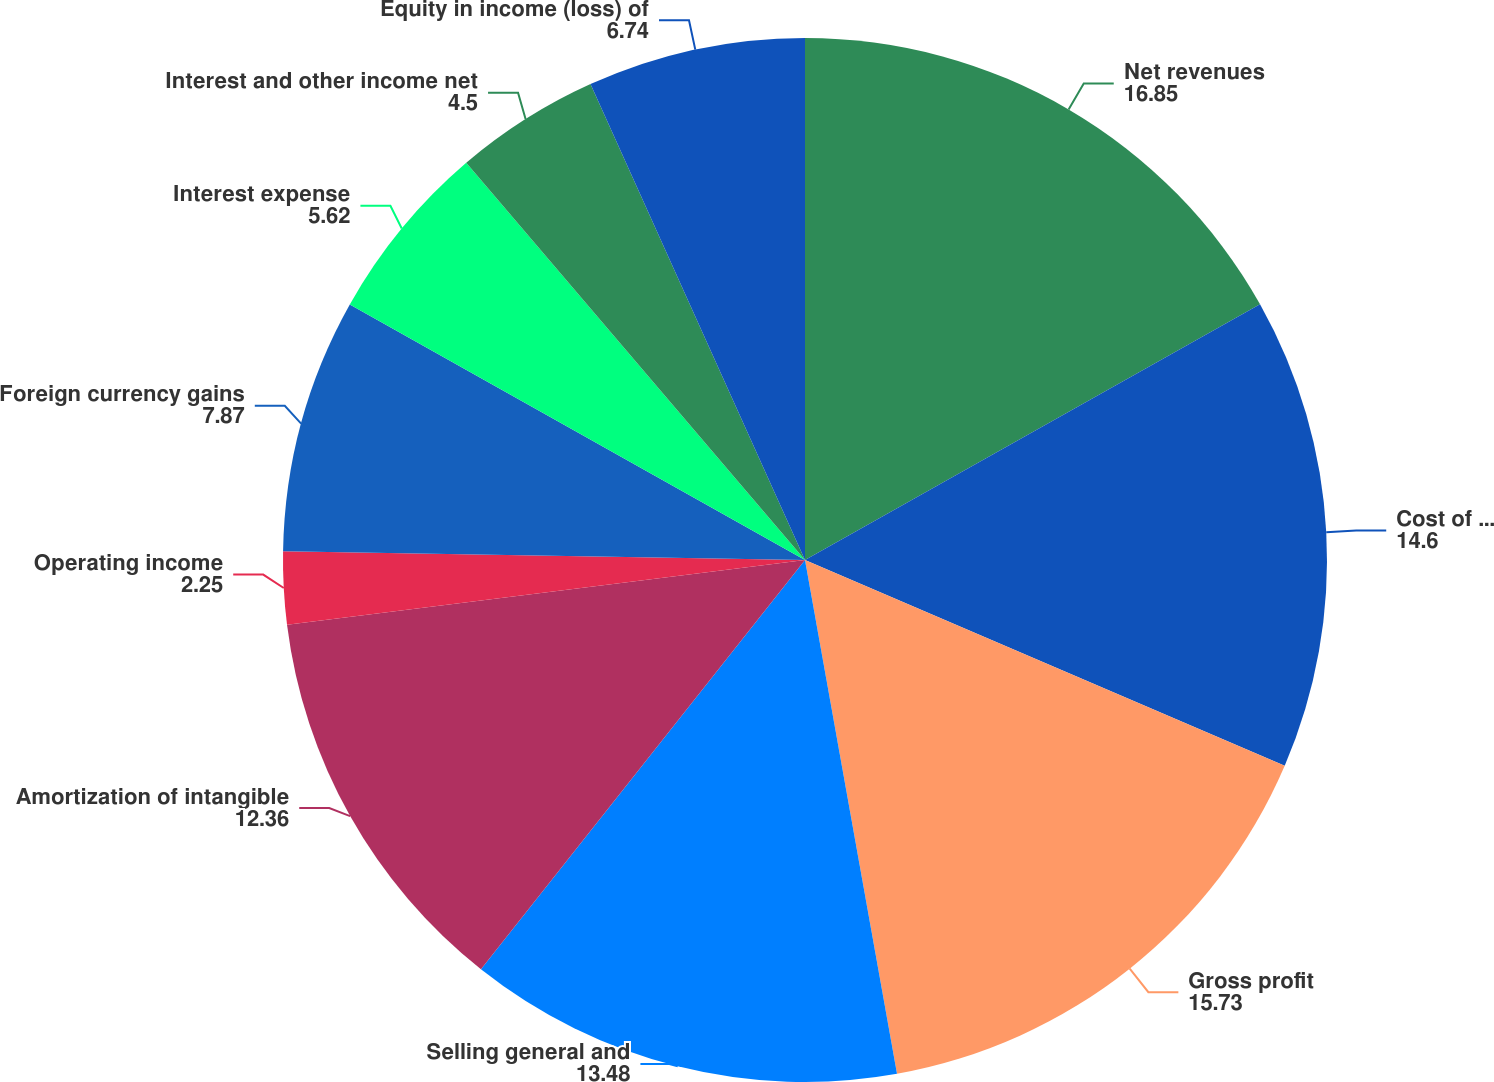<chart> <loc_0><loc_0><loc_500><loc_500><pie_chart><fcel>Net revenues<fcel>Cost of goods sold ^(a)<fcel>Gross profit<fcel>Selling general and<fcel>Amortization of intangible<fcel>Operating income<fcel>Foreign currency gains<fcel>Interest expense<fcel>Interest and other income net<fcel>Equity in income (loss) of<nl><fcel>16.85%<fcel>14.6%<fcel>15.73%<fcel>13.48%<fcel>12.36%<fcel>2.25%<fcel>7.87%<fcel>5.62%<fcel>4.5%<fcel>6.74%<nl></chart> 